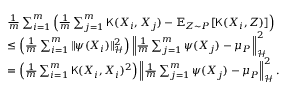Convert formula to latex. <formula><loc_0><loc_0><loc_500><loc_500>\begin{array} { r l } & { \frac { 1 } { m } \sum _ { i = 1 } ^ { m } \left ( \frac { 1 } { m } \sum _ { j = 1 } ^ { m } { \mathsf K } ( X _ { i } , X _ { j } ) - \mathbb { E } _ { Z \sim P } [ { \mathsf K } ( X _ { i } , Z ) ] \right ) } \\ & { \leq \left ( \frac { 1 } { m } \sum _ { i = 1 } ^ { m } \| \psi ( X _ { i } ) \| _ { \mathcal { H } } ^ { 2 } \right ) \left \| \frac { 1 } { m } \sum _ { j = 1 } ^ { m } \psi ( X _ { j } ) - \mu _ { P } \right \| _ { \mathcal { H } } ^ { 2 } } \\ & { = \left ( \frac { 1 } { m } \sum _ { i = 1 } ^ { m } { \mathsf K } ( X _ { i } , X _ { i } ) ^ { 2 } \right ) \left \| \frac { 1 } { m } \sum _ { j = 1 } ^ { m } \psi ( X _ { j } ) - \mu _ { P } \right \| _ { \mathcal { H } } ^ { 2 } . } \end{array}</formula> 